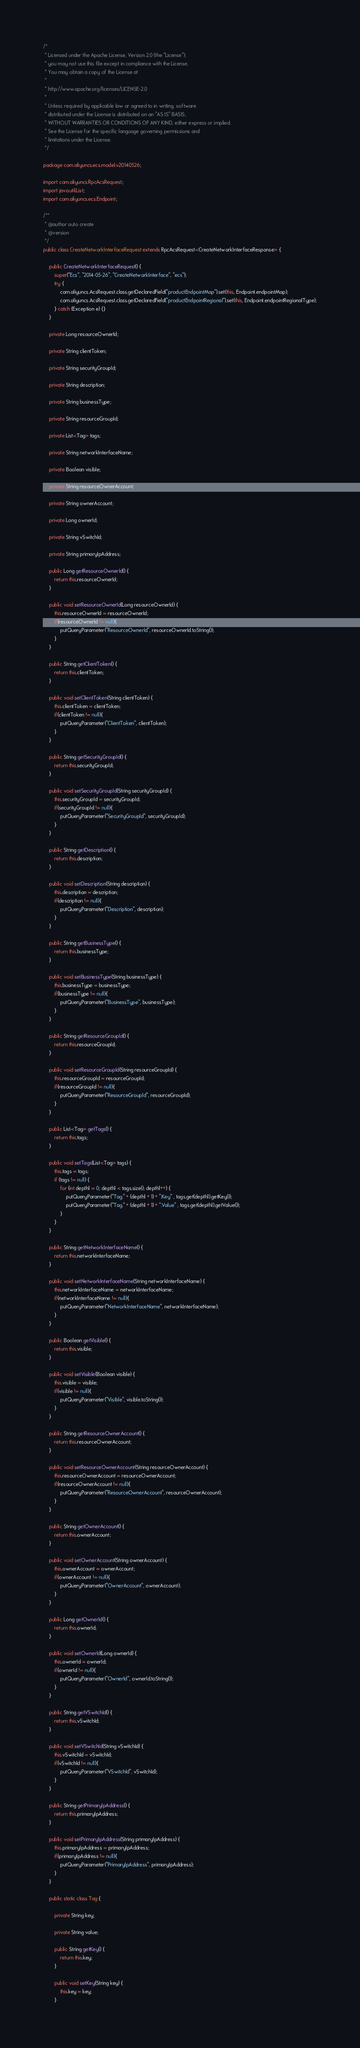<code> <loc_0><loc_0><loc_500><loc_500><_Java_>/*
 * Licensed under the Apache License, Version 2.0 (the "License");
 * you may not use this file except in compliance with the License.
 * You may obtain a copy of the License at
 *
 * http://www.apache.org/licenses/LICENSE-2.0
 *
 * Unless required by applicable law or agreed to in writing, software
 * distributed under the License is distributed on an "AS IS" BASIS,
 * WITHOUT WARRANTIES OR CONDITIONS OF ANY KIND, either express or implied.
 * See the License for the specific language governing permissions and
 * limitations under the License.
 */

package com.aliyuncs.ecs.model.v20140526;

import com.aliyuncs.RpcAcsRequest;
import java.util.List;
import com.aliyuncs.ecs.Endpoint;

/**
 * @author auto create
 * @version 
 */
public class CreateNetworkInterfaceRequest extends RpcAcsRequest<CreateNetworkInterfaceResponse> {
	
	public CreateNetworkInterfaceRequest() {
		super("Ecs", "2014-05-26", "CreateNetworkInterface", "ecs");
		try {
			com.aliyuncs.AcsRequest.class.getDeclaredField("productEndpointMap").set(this, Endpoint.endpointMap);
			com.aliyuncs.AcsRequest.class.getDeclaredField("productEndpointRegional").set(this, Endpoint.endpointRegionalType);
		} catch (Exception e) {}
	}

	private Long resourceOwnerId;

	private String clientToken;

	private String securityGroupId;

	private String description;

	private String businessType;

	private String resourceGroupId;

	private List<Tag> tags;

	private String networkInterfaceName;

	private Boolean visible;

	private String resourceOwnerAccount;

	private String ownerAccount;

	private Long ownerId;

	private String vSwitchId;

	private String primaryIpAddress;

	public Long getResourceOwnerId() {
		return this.resourceOwnerId;
	}

	public void setResourceOwnerId(Long resourceOwnerId) {
		this.resourceOwnerId = resourceOwnerId;
		if(resourceOwnerId != null){
			putQueryParameter("ResourceOwnerId", resourceOwnerId.toString());
		}
	}

	public String getClientToken() {
		return this.clientToken;
	}

	public void setClientToken(String clientToken) {
		this.clientToken = clientToken;
		if(clientToken != null){
			putQueryParameter("ClientToken", clientToken);
		}
	}

	public String getSecurityGroupId() {
		return this.securityGroupId;
	}

	public void setSecurityGroupId(String securityGroupId) {
		this.securityGroupId = securityGroupId;
		if(securityGroupId != null){
			putQueryParameter("SecurityGroupId", securityGroupId);
		}
	}

	public String getDescription() {
		return this.description;
	}

	public void setDescription(String description) {
		this.description = description;
		if(description != null){
			putQueryParameter("Description", description);
		}
	}

	public String getBusinessType() {
		return this.businessType;
	}

	public void setBusinessType(String businessType) {
		this.businessType = businessType;
		if(businessType != null){
			putQueryParameter("BusinessType", businessType);
		}
	}

	public String getResourceGroupId() {
		return this.resourceGroupId;
	}

	public void setResourceGroupId(String resourceGroupId) {
		this.resourceGroupId = resourceGroupId;
		if(resourceGroupId != null){
			putQueryParameter("ResourceGroupId", resourceGroupId);
		}
	}

	public List<Tag> getTags() {
		return this.tags;
	}

	public void setTags(List<Tag> tags) {
		this.tags = tags;	
		if (tags != null) {
			for (int depth1 = 0; depth1 < tags.size(); depth1++) {
				putQueryParameter("Tag." + (depth1 + 1) + ".Key" , tags.get(depth1).getKey());
				putQueryParameter("Tag." + (depth1 + 1) + ".Value" , tags.get(depth1).getValue());
			}
		}	
	}

	public String getNetworkInterfaceName() {
		return this.networkInterfaceName;
	}

	public void setNetworkInterfaceName(String networkInterfaceName) {
		this.networkInterfaceName = networkInterfaceName;
		if(networkInterfaceName != null){
			putQueryParameter("NetworkInterfaceName", networkInterfaceName);
		}
	}

	public Boolean getVisible() {
		return this.visible;
	}

	public void setVisible(Boolean visible) {
		this.visible = visible;
		if(visible != null){
			putQueryParameter("Visible", visible.toString());
		}
	}

	public String getResourceOwnerAccount() {
		return this.resourceOwnerAccount;
	}

	public void setResourceOwnerAccount(String resourceOwnerAccount) {
		this.resourceOwnerAccount = resourceOwnerAccount;
		if(resourceOwnerAccount != null){
			putQueryParameter("ResourceOwnerAccount", resourceOwnerAccount);
		}
	}

	public String getOwnerAccount() {
		return this.ownerAccount;
	}

	public void setOwnerAccount(String ownerAccount) {
		this.ownerAccount = ownerAccount;
		if(ownerAccount != null){
			putQueryParameter("OwnerAccount", ownerAccount);
		}
	}

	public Long getOwnerId() {
		return this.ownerId;
	}

	public void setOwnerId(Long ownerId) {
		this.ownerId = ownerId;
		if(ownerId != null){
			putQueryParameter("OwnerId", ownerId.toString());
		}
	}

	public String getVSwitchId() {
		return this.vSwitchId;
	}

	public void setVSwitchId(String vSwitchId) {
		this.vSwitchId = vSwitchId;
		if(vSwitchId != null){
			putQueryParameter("VSwitchId", vSwitchId);
		}
	}

	public String getPrimaryIpAddress() {
		return this.primaryIpAddress;
	}

	public void setPrimaryIpAddress(String primaryIpAddress) {
		this.primaryIpAddress = primaryIpAddress;
		if(primaryIpAddress != null){
			putQueryParameter("PrimaryIpAddress", primaryIpAddress);
		}
	}

	public static class Tag {

		private String key;

		private String value;

		public String getKey() {
			return this.key;
		}

		public void setKey(String key) {
			this.key = key;
		}
</code> 